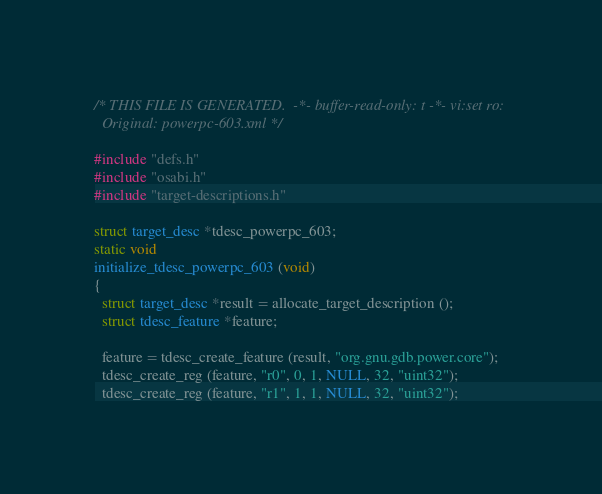<code> <loc_0><loc_0><loc_500><loc_500><_C_>/* THIS FILE IS GENERATED.  -*- buffer-read-only: t -*- vi:set ro:
  Original: powerpc-603.xml */

#include "defs.h"
#include "osabi.h"
#include "target-descriptions.h"

struct target_desc *tdesc_powerpc_603;
static void
initialize_tdesc_powerpc_603 (void)
{
  struct target_desc *result = allocate_target_description ();
  struct tdesc_feature *feature;

  feature = tdesc_create_feature (result, "org.gnu.gdb.power.core");
  tdesc_create_reg (feature, "r0", 0, 1, NULL, 32, "uint32");
  tdesc_create_reg (feature, "r1", 1, 1, NULL, 32, "uint32");</code> 